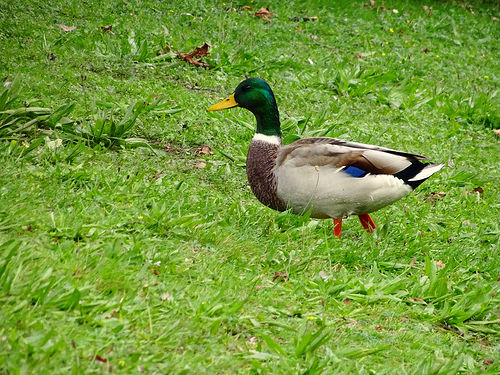<image>
Can you confirm if the grass is under the leaf? Yes. The grass is positioned underneath the leaf, with the leaf above it in the vertical space. Is there a duck on the grace? Yes. Looking at the image, I can see the duck is positioned on top of the grace, with the grace providing support. 